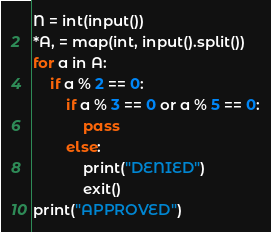<code> <loc_0><loc_0><loc_500><loc_500><_Python_>
N = int(input())
*A, = map(int, input().split())
for a in A:
    if a % 2 == 0:
        if a % 3 == 0 or a % 5 == 0:
            pass
        else:
            print("DENIED")
            exit()
print("APPROVED")</code> 